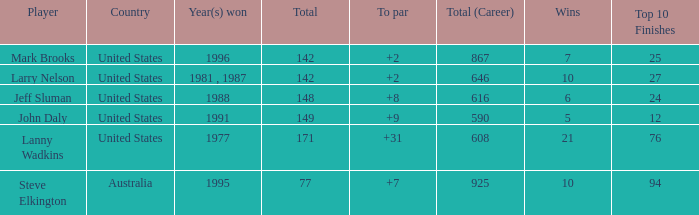Name the Total of australia and a To par smaller than 7? None. 